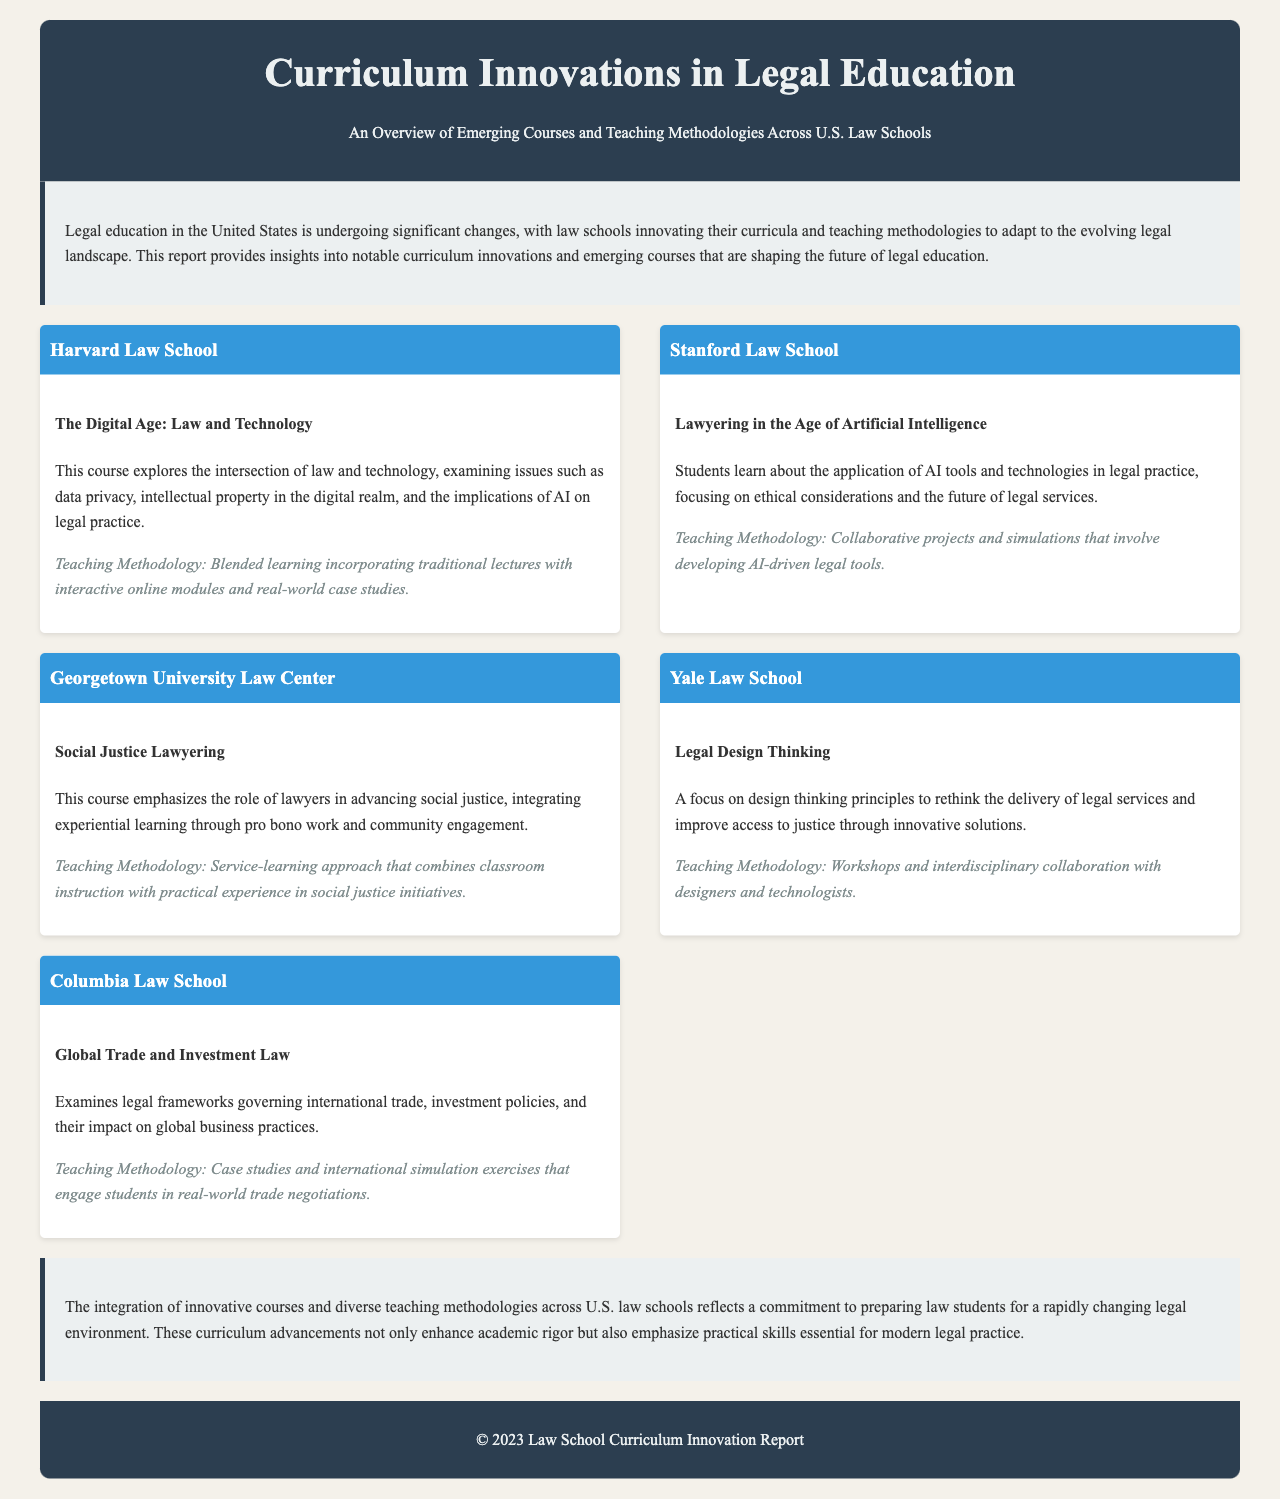What is the title of the report? The title is the main header of the document, providing insight into the report's focus.
Answer: Curriculum Innovations in Legal Education Which law school offers a course on Law and Technology? This question targets a specific course mentioned in the innovations section.
Answer: Harvard Law School What teaching methodology is used in the Social Justice Lawyering course? The methodology is highlighted under each innovation's content, focusing on teaching approaches.
Answer: Service-learning approach How many law schools are discussed in the report? This question asks for the total number of law schools that have innovative courses mentioned.
Answer: Five What is the focus of the Global Trade and Investment Law course? The focus of the course provides insight into its content and significance in legal education.
Answer: International trade and investment policies What kind of approach does Yale Law School take in its Legal Design Thinking course? The specific approach is mentioned to understand the unique educational strategy employed.
Answer: Workshops and interdisciplinary collaboration Which law school emphasizes AI technologies in legal practice? This identifies a specific focus area within the curriculum innovations presented.
Answer: Stanford Law School What is the overall theme of the document's conclusion? The conclusion summarizes the document's findings and emphasizes a key takeaway.
Answer: Preparing law students for a rapidly changing legal environment 